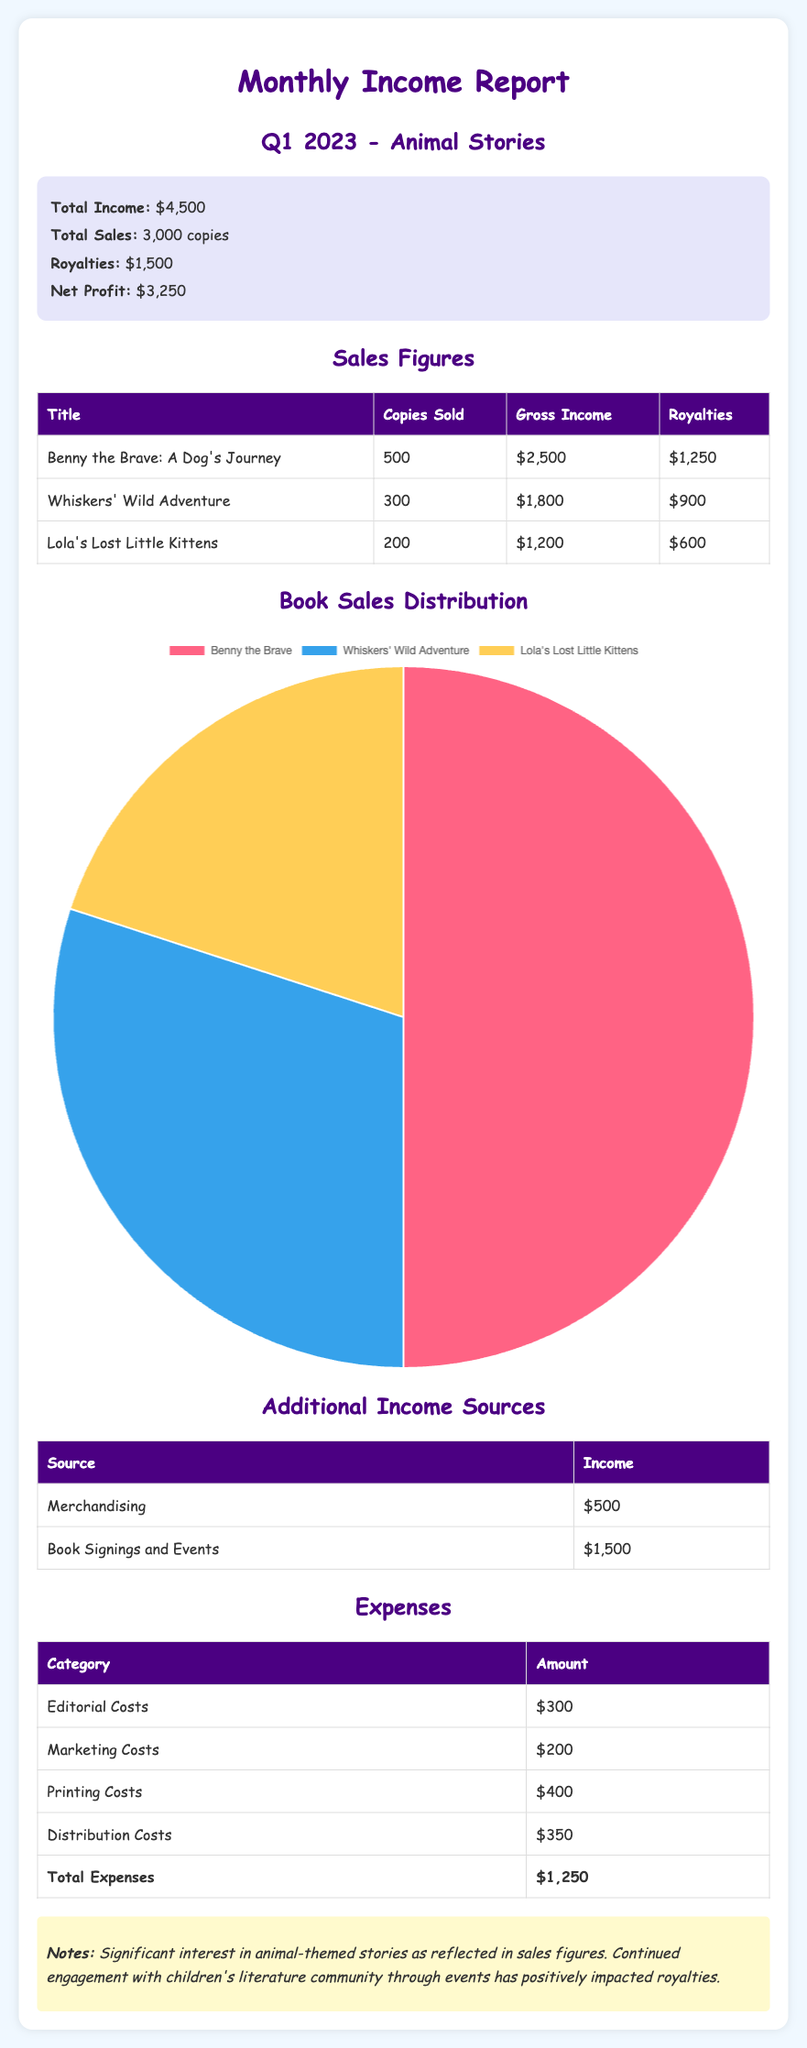What is the total income? The total income is provided in the summary section of the report.
Answer: $4,500 How many copies of "Lola's Lost Little Kittens" were sold? The number of copies sold for each title is listed in the sales figures table.
Answer: 200 What is the royalty amount for "Benny the Brave: A Dog's Journey"? The royalties for each title are detailed in the sales figures table.
Answer: $1,250 What were the total expenses? The total expenses are calculated and provided at the end of the expenses table.
Answer: $1,250 What is the net profit? The net profit is found in the summary section, calculated as total income minus total expenses.
Answer: $3,250 How much income was generated from book signings and events? The income from additional sources is listed in the additional income sources table.
Answer: $1,500 Which title had the highest gross income? The gross income figures for each title are shown in the sales figures table, indicating which title earned the most.
Answer: Benny the Brave: A Dog's Journey What is the income generated from merchandising? The income from merchandising is specified in the additional income sources table.
Answer: $500 What is the total sales of all titles combined? The total sales figure is provided in the summary section of the report.
Answer: 3,000 copies 